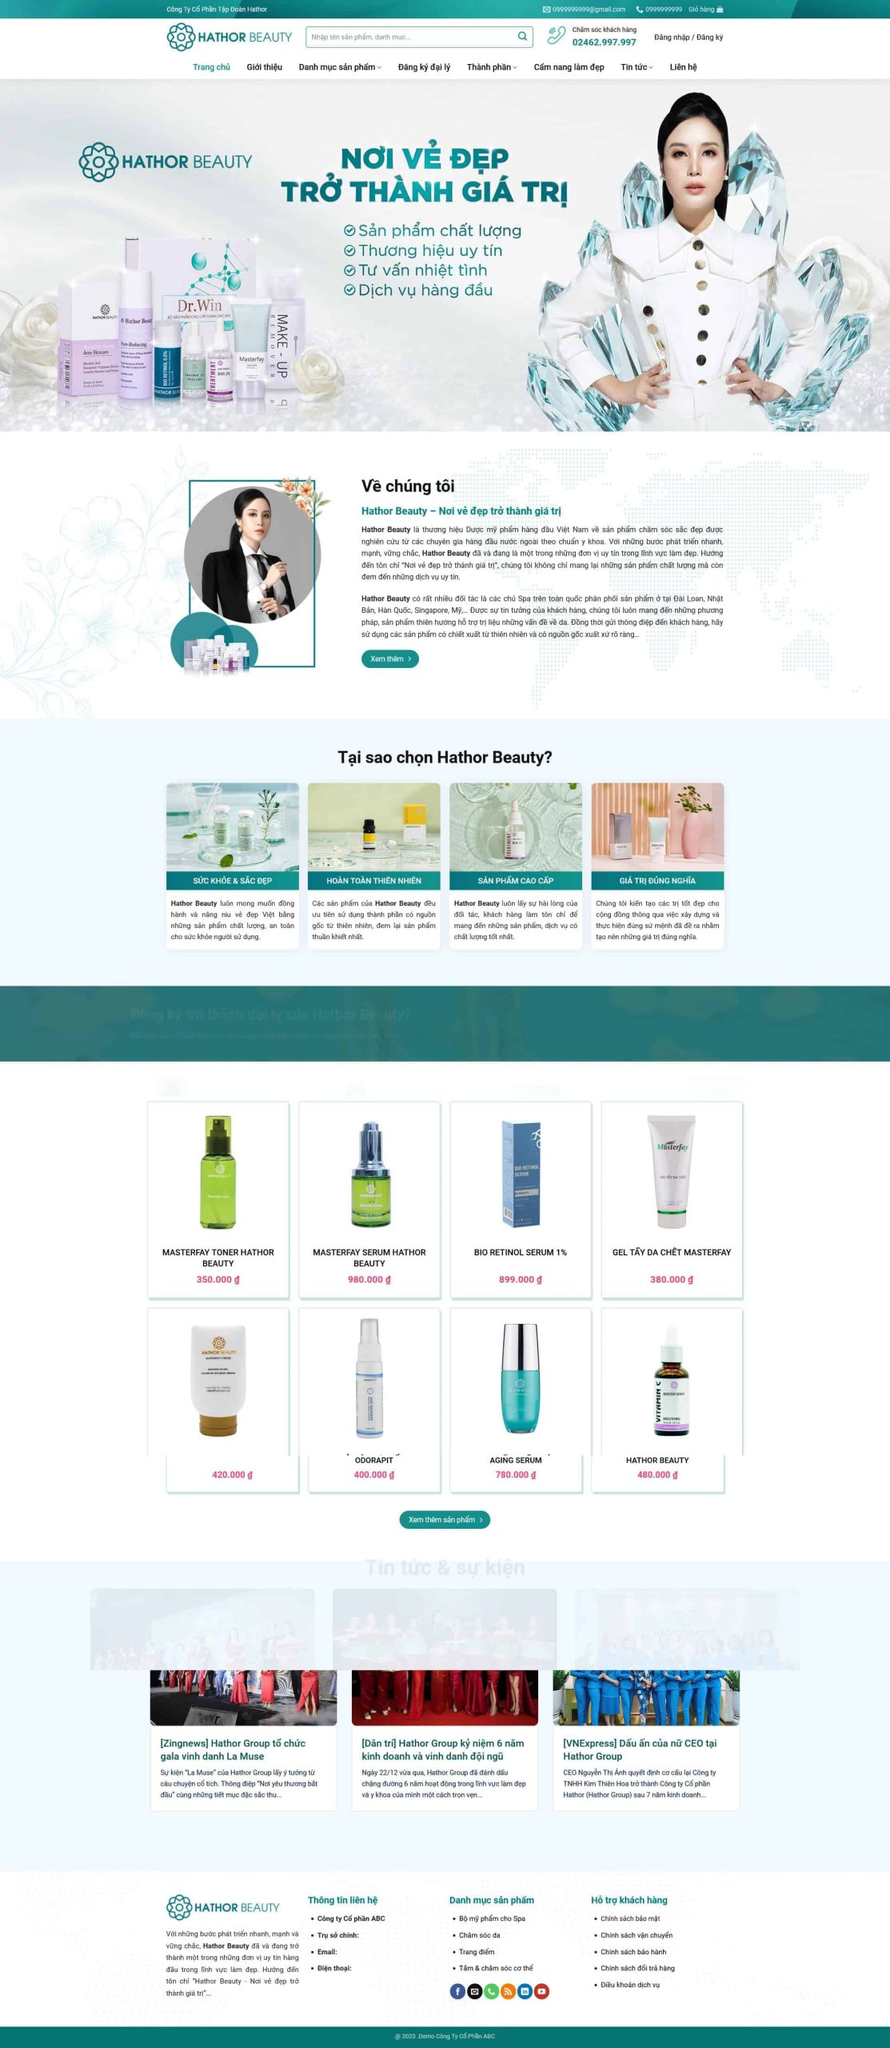Liệt kê 5 ngành nghề, lĩnh vực phù hợp với website này, phân cách các màu sắc bằng dấu phẩy. Chỉ trả về kết quả, phân cách bằng dấy phẩy
 Mỹ phẩm, Chăm sóc da, Spa, Sức khỏe và sắc đẹp, Dược mỹ phẩm 